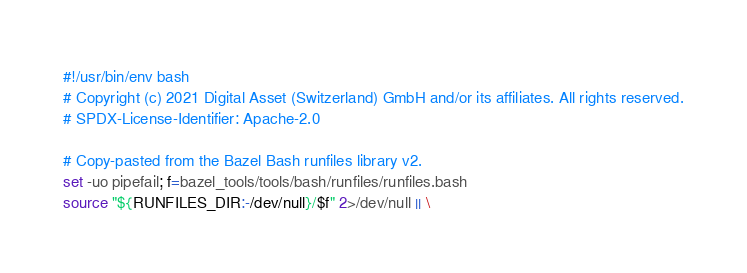Convert code to text. <code><loc_0><loc_0><loc_500><loc_500><_Bash_>#!/usr/bin/env bash
# Copyright (c) 2021 Digital Asset (Switzerland) GmbH and/or its affiliates. All rights reserved.
# SPDX-License-Identifier: Apache-2.0

# Copy-pasted from the Bazel Bash runfiles library v2.
set -uo pipefail; f=bazel_tools/tools/bash/runfiles/runfiles.bash
source "${RUNFILES_DIR:-/dev/null}/$f" 2>/dev/null || \</code> 